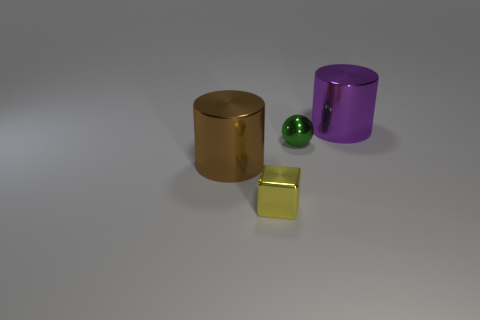Add 4 small metal objects. How many objects exist? 8 Subtract all blocks. How many objects are left? 3 Add 4 metal things. How many metal things are left? 8 Add 3 small rubber cylinders. How many small rubber cylinders exist? 3 Subtract 1 yellow cubes. How many objects are left? 3 Subtract all small green objects. Subtract all big metal cylinders. How many objects are left? 1 